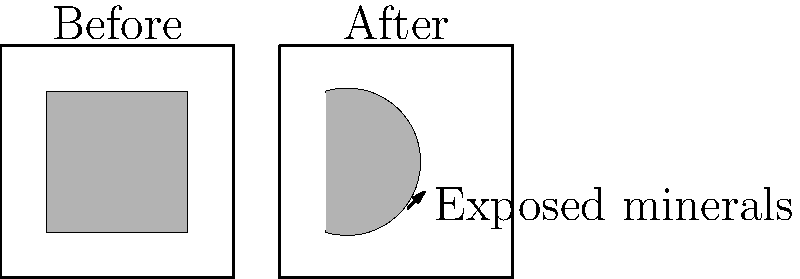Based on the before-and-after diagrams of glacial erosion, which of the following statements is most accurate regarding the impact on mineral exposure?

A) Glacial erosion has decreased the total surface area of exposed minerals.
B) The erosion pattern has created a uniform distribution of exposed minerals.
C) Glacial activity has resulted in a more concentrated exposure of minerals in specific areas.
D) The erosion has had no significant impact on mineral exposure patterns. To analyze the impact of glacial erosion on mineral exposure, let's examine the diagrams step-by-step:

1. Before erosion:
   - The exposed minerals (represented by the gray area) form a large, uniform square in the center of the diagram.
   - The total surface area of exposed minerals is relatively large and evenly distributed.

2. After erosion:
   - The exposed minerals now form a curved, irregular shape.
   - The total surface area of exposed minerals appears to be smaller than in the "Before" diagram.
   - The distribution of exposed minerals is concentrated on one side of the diagram, creating a more localized exposure pattern.

3. Comparing the two diagrams:
   - The erosion has clearly altered the shape and distribution of exposed minerals.
   - The uniform square has been transformed into an irregular, curved shape.
   - The concentration of exposed minerals has shifted to one side, indicating a more focused area of exposure.

4. Impact on mineral exposure:
   - The total surface area of exposed minerals has decreased.
   - The distribution of exposed minerals has become less uniform and more concentrated in specific areas.

5. Conclusion:
   - The most accurate statement is that glacial activity has resulted in a more concentrated exposure of minerals in specific areas.
   - This conclusion aligns with option C in the question.

The glacial erosion has carved out a portion of the original mineral deposit, leaving behind a more focused area of exposure. This pattern is typical in glacial landscapes, where erosion can create localized areas of mineral concentration, potentially making them more accessible for geological exploration and mining activities.
Answer: C) Glacial activity has resulted in a more concentrated exposure of minerals in specific areas. 